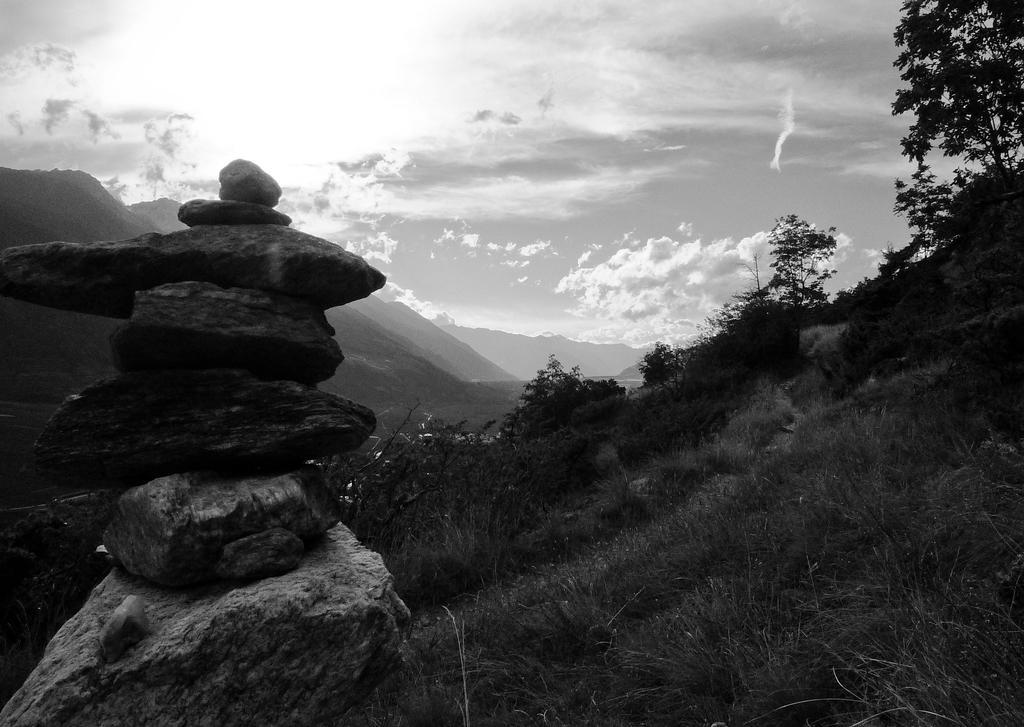Describe this image in one or two sentences. In this image I can see few mountains, trees, stones, grass and the sky. The image is in black and white. 